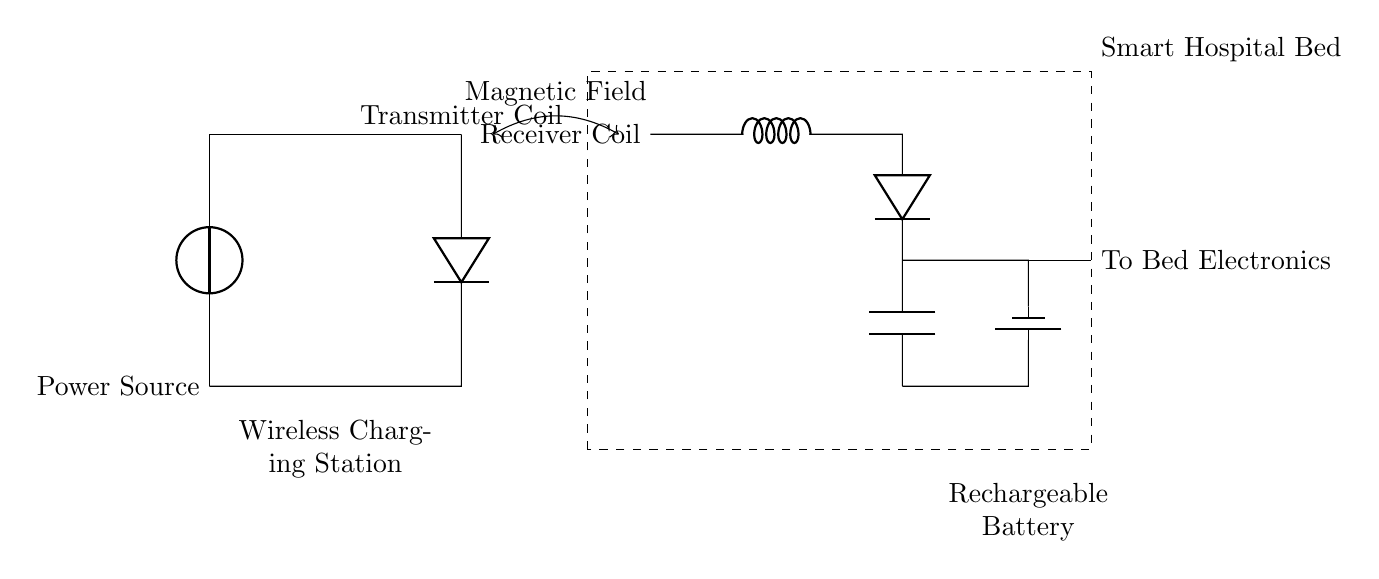What component generates power in this circuit? The power source is indicated as the component providing voltage, located on the left side of the diagram.
Answer: Power source What process transfers energy from the transmitter to the receiver? The energy is transferred via a magnetic field, as indicated by the labeled double arrow between the transmitter coil and the receiver coil.
Answer: Magnetic field What type of power source is used in this circuit? The circuit diagram depicts a voltage source as the power source, typically representing a battery or power supply.
Answer: Voltage source How many coils are in this wireless charging circuit? The diagram shows one transmitter coil and one receiver coil, giving a total of two distinct coils involved in the wireless power transfer process.
Answer: Two What is the output of the rechargeable battery? The rechargeable battery stores energy, and the output connection is labeled as "To Bed Electronics," which suggests it is supplying power to the bed's systems.
Answer: To Bed Electronics Which component is responsible for voltage regulation in the receiver part of the circuit? The circuit diagram does not explicitly show a voltage regulation component; however, the presence of a battery indicates it is providing regulated output for the bed electronics.
Answer: Battery How is the rechargeable battery charged in this design? The rechargeable battery is charged through the energy received by the receiver coil in the smart hospital bed from the transmitter coil via the magnetic field.
Answer: Via magnetic field 